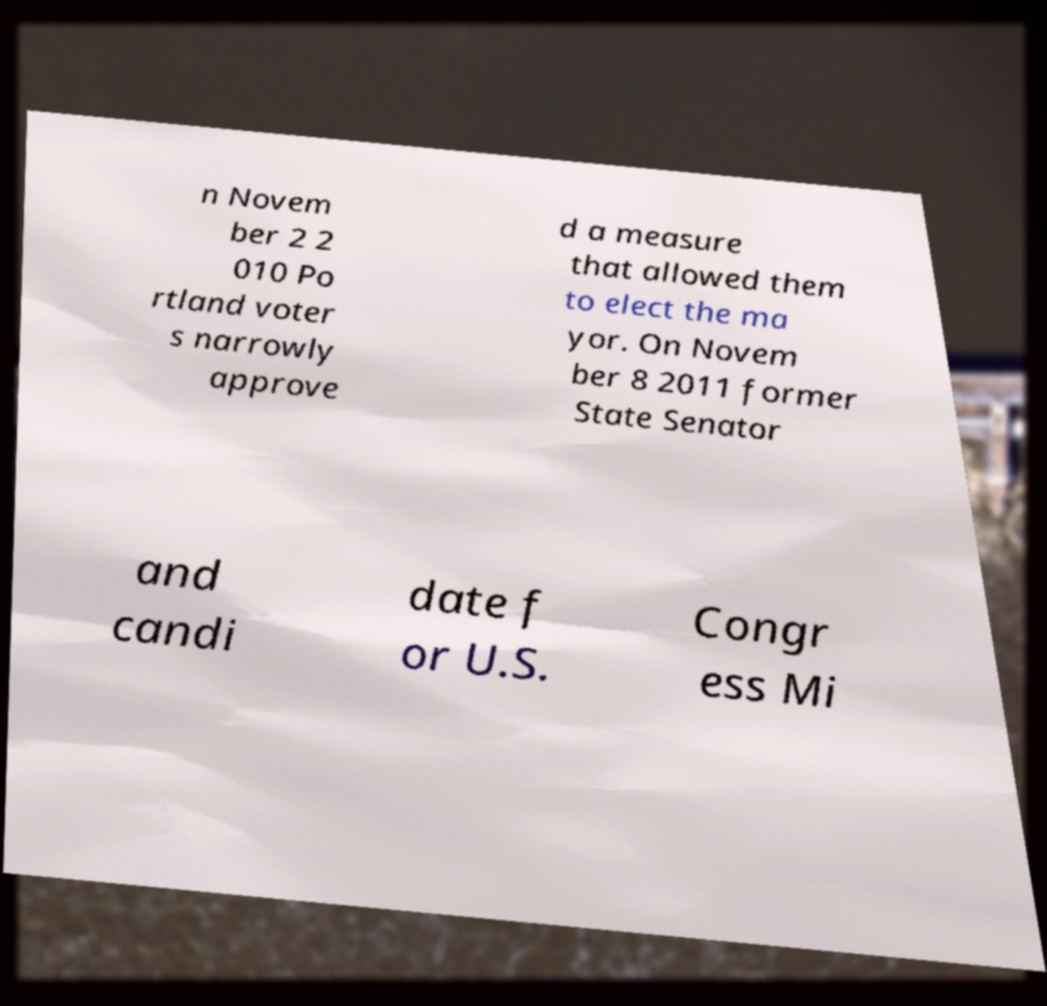For documentation purposes, I need the text within this image transcribed. Could you provide that? n Novem ber 2 2 010 Po rtland voter s narrowly approve d a measure that allowed them to elect the ma yor. On Novem ber 8 2011 former State Senator and candi date f or U.S. Congr ess Mi 